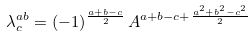<formula> <loc_0><loc_0><loc_500><loc_500>\lambda ^ { a b } _ { c } = ( - 1 ) ^ { \frac { a + b - c } { 2 } } \, A ^ { a + b - c + \frac { a ^ { 2 } + b ^ { 2 } - c ^ { 2 } } { 2 } } \,</formula> 